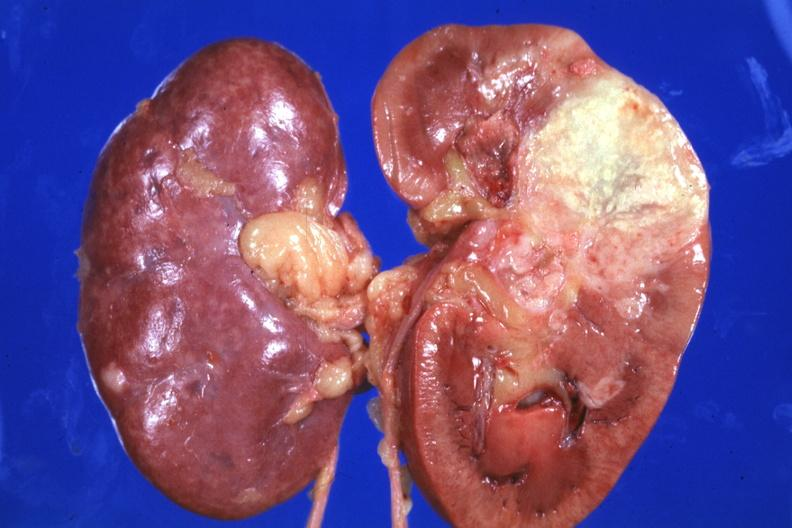s metastatic carcinoma lung present?
Answer the question using a single word or phrase. Yes 